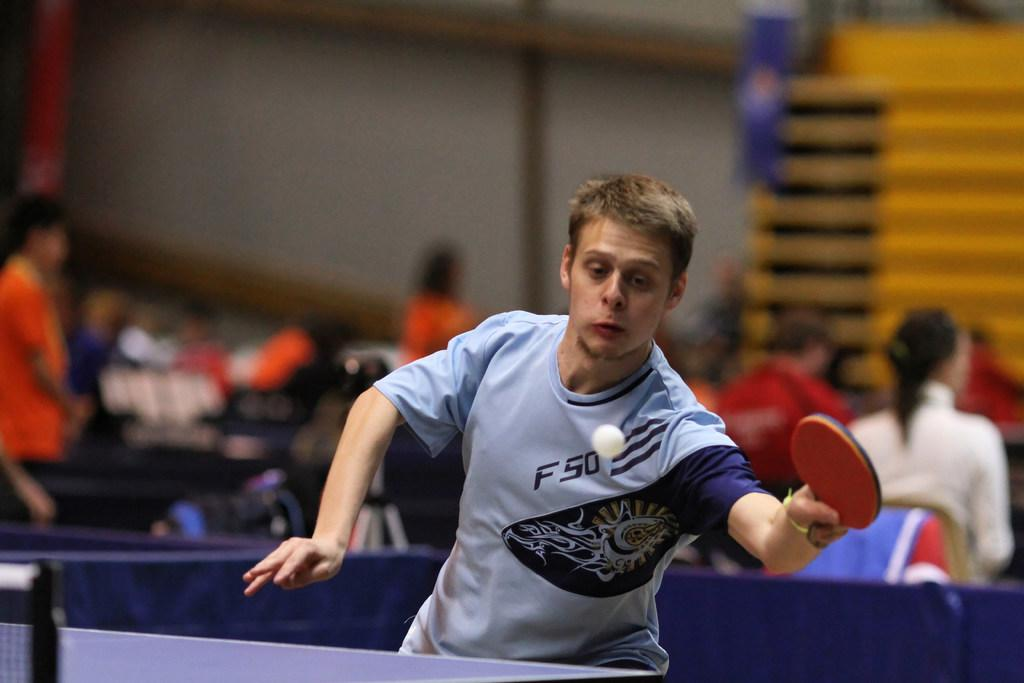<image>
Render a clear and concise summary of the photo. A man in an FSO shirt plays ping pong in front of a crowd. 